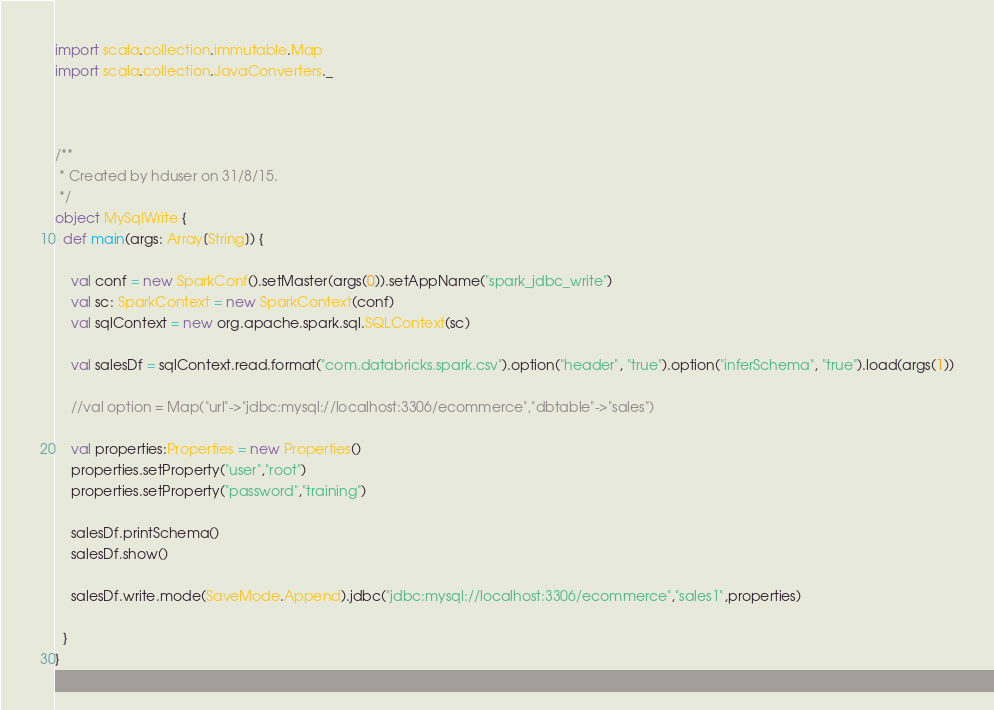<code> <loc_0><loc_0><loc_500><loc_500><_Scala_>
import scala.collection.immutable.Map
import scala.collection.JavaConverters._



/**
 * Created by hduser on 31/8/15.
 */
object MySqlWrite {
  def main(args: Array[String]) {

    val conf = new SparkConf().setMaster(args(0)).setAppName("spark_jdbc_write")
    val sc: SparkContext = new SparkContext(conf)
    val sqlContext = new org.apache.spark.sql.SQLContext(sc)

    val salesDf = sqlContext.read.format("com.databricks.spark.csv").option("header", "true").option("inferSchema", "true").load(args(1))

    //val option = Map("url"->"jdbc:mysql://localhost:3306/ecommerce","dbtable"->"sales")

    val properties:Properties = new Properties()
    properties.setProperty("user","root")
    properties.setProperty("password","training")

    salesDf.printSchema()
    salesDf.show()

    salesDf.write.mode(SaveMode.Append).jdbc("jdbc:mysql://localhost:3306/ecommerce","sales1",properties)

  }
}
</code> 